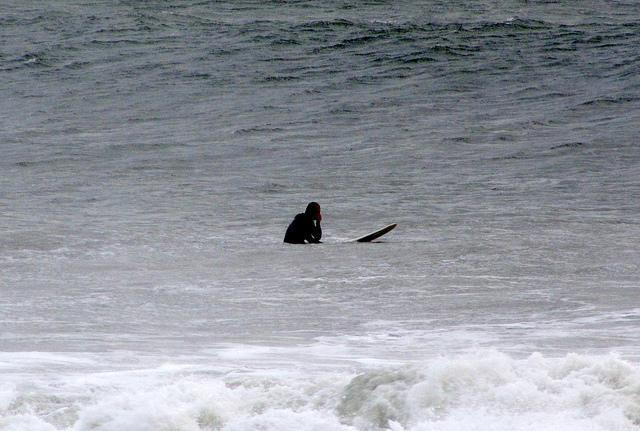How many black cats are there in the image ?
Give a very brief answer. 0. 